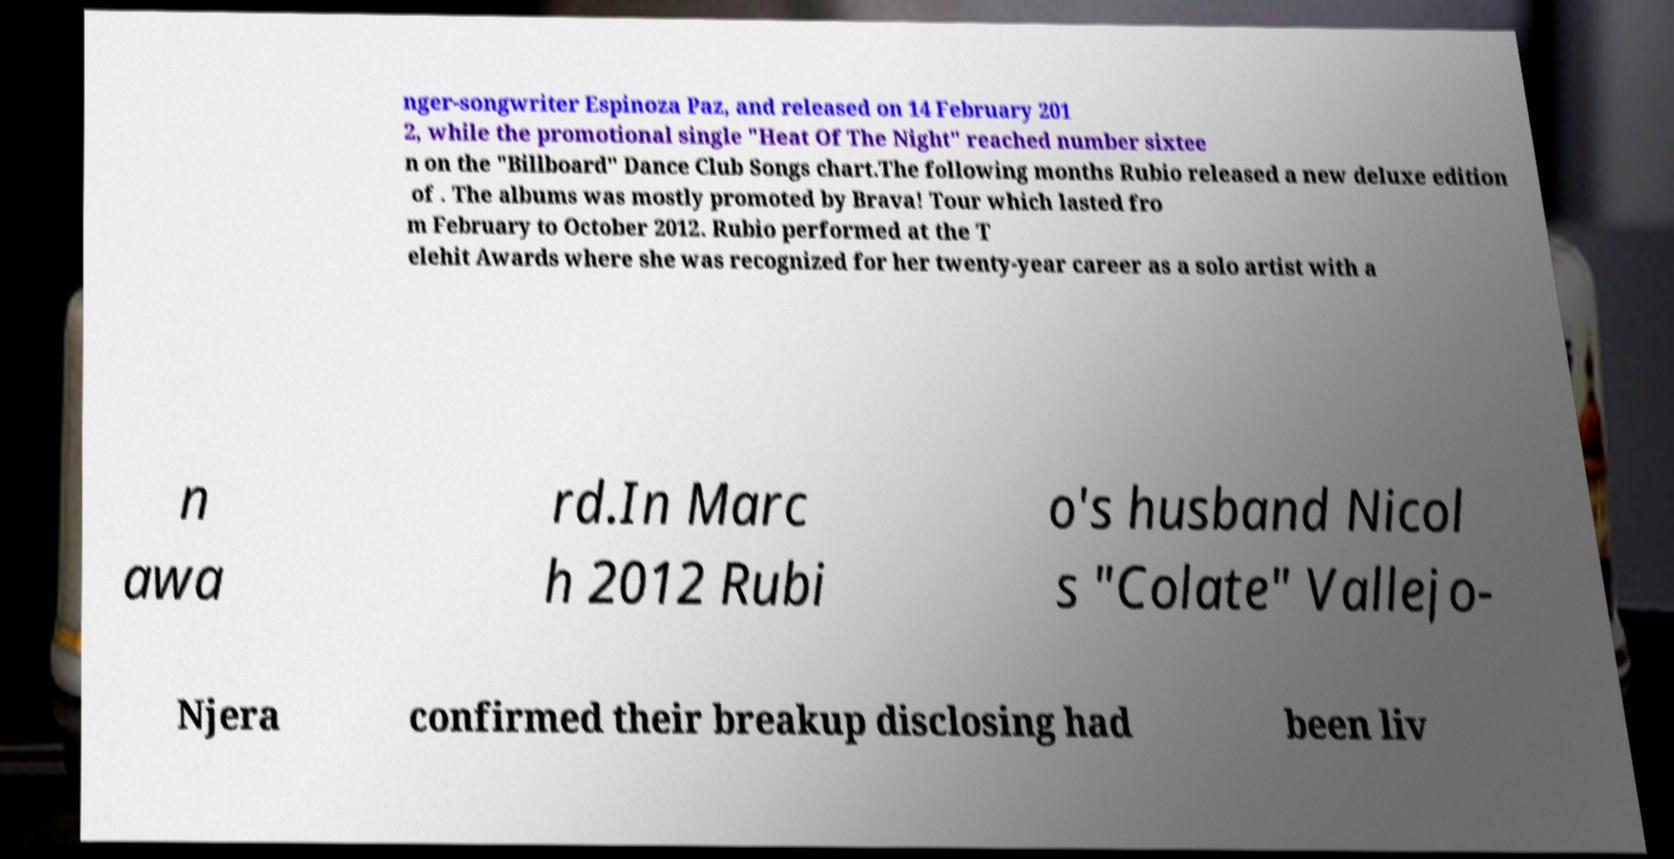There's text embedded in this image that I need extracted. Can you transcribe it verbatim? nger-songwriter Espinoza Paz, and released on 14 February 201 2, while the promotional single "Heat Of The Night" reached number sixtee n on the "Billboard" Dance Club Songs chart.The following months Rubio released a new deluxe edition of . The albums was mostly promoted by Brava! Tour which lasted fro m February to October 2012. Rubio performed at the T elehit Awards where she was recognized for her twenty-year career as a solo artist with a n awa rd.In Marc h 2012 Rubi o's husband Nicol s "Colate" Vallejo- Njera confirmed their breakup disclosing had been liv 